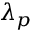<formula> <loc_0><loc_0><loc_500><loc_500>\lambda _ { p }</formula> 